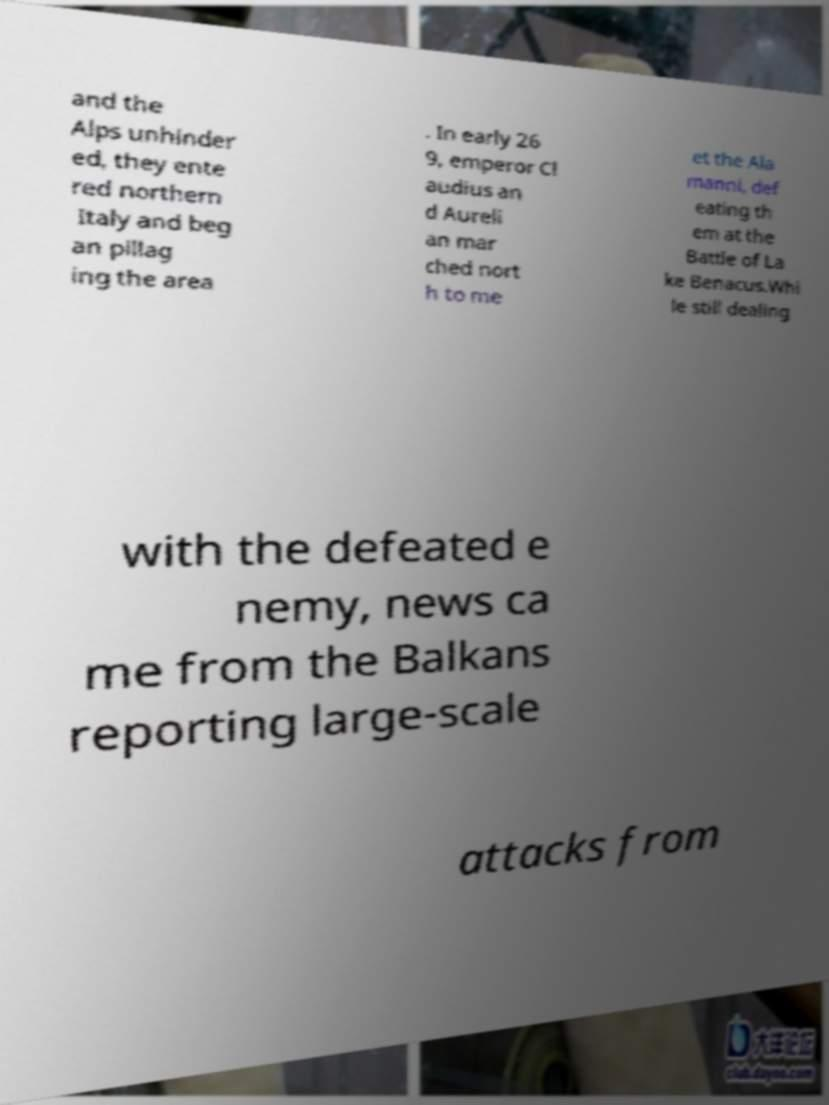Please read and relay the text visible in this image. What does it say? and the Alps unhinder ed, they ente red northern Italy and beg an pillag ing the area . In early 26 9, emperor Cl audius an d Aureli an mar ched nort h to me et the Ala manni, def eating th em at the Battle of La ke Benacus.Whi le still dealing with the defeated e nemy, news ca me from the Balkans reporting large-scale attacks from 